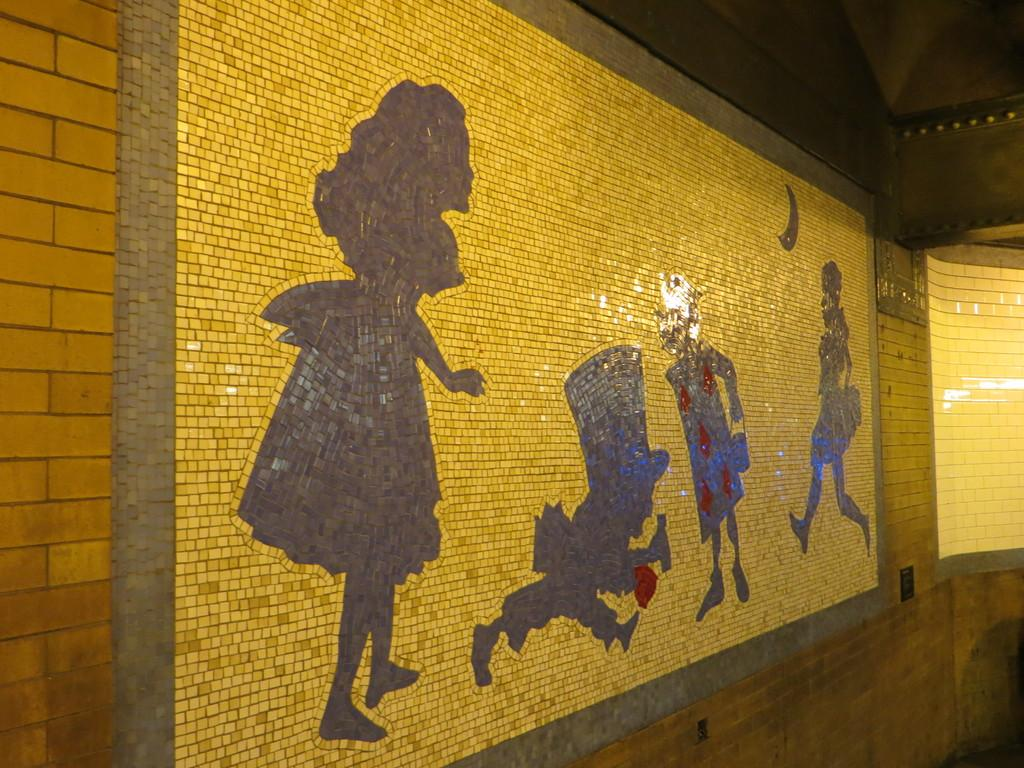What is present on the wall in the image? There is an art piece on the wall in the image. How many clocks are hanging on the wall in the image? There are no clocks visible on the wall in the image; it only contains an art piece. What type of committee is meeting in front of the wall in the image? There is no committee meeting in front of the wall in the image. Is there a kite flying in front of the wall in the image? There is no kite visible in front of the wall in the image. 